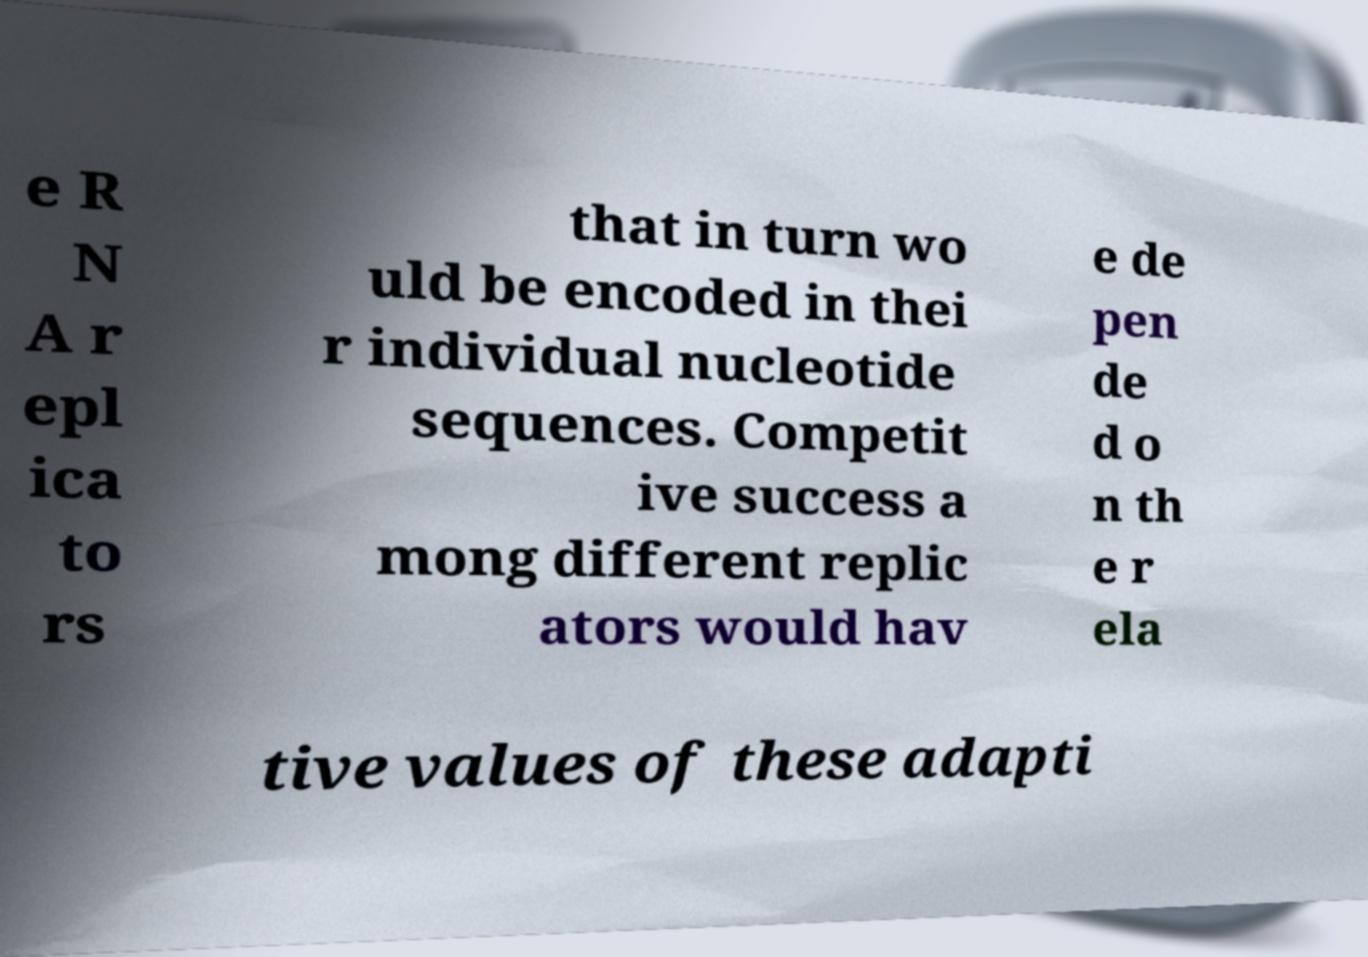Please identify and transcribe the text found in this image. e R N A r epl ica to rs that in turn wo uld be encoded in thei r individual nucleotide sequences. Competit ive success a mong different replic ators would hav e de pen de d o n th e r ela tive values of these adapti 